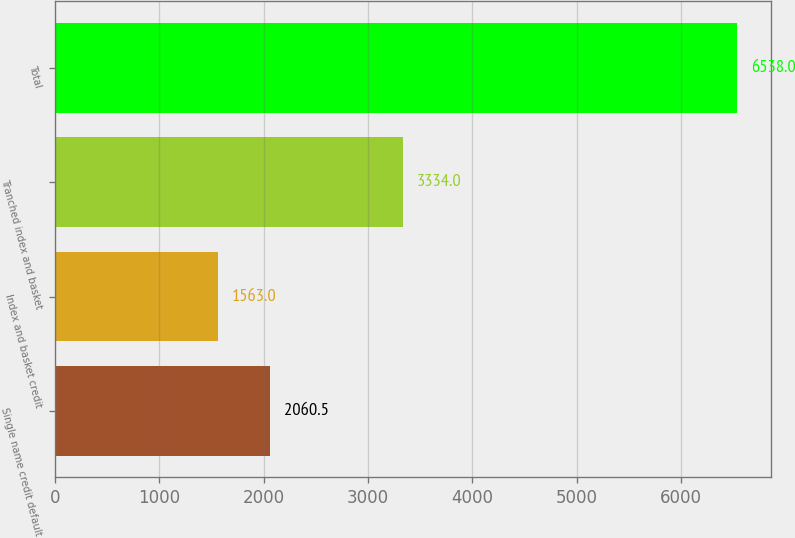Convert chart. <chart><loc_0><loc_0><loc_500><loc_500><bar_chart><fcel>Single name credit default<fcel>Index and basket credit<fcel>Tranched index and basket<fcel>Total<nl><fcel>2060.5<fcel>1563<fcel>3334<fcel>6538<nl></chart> 